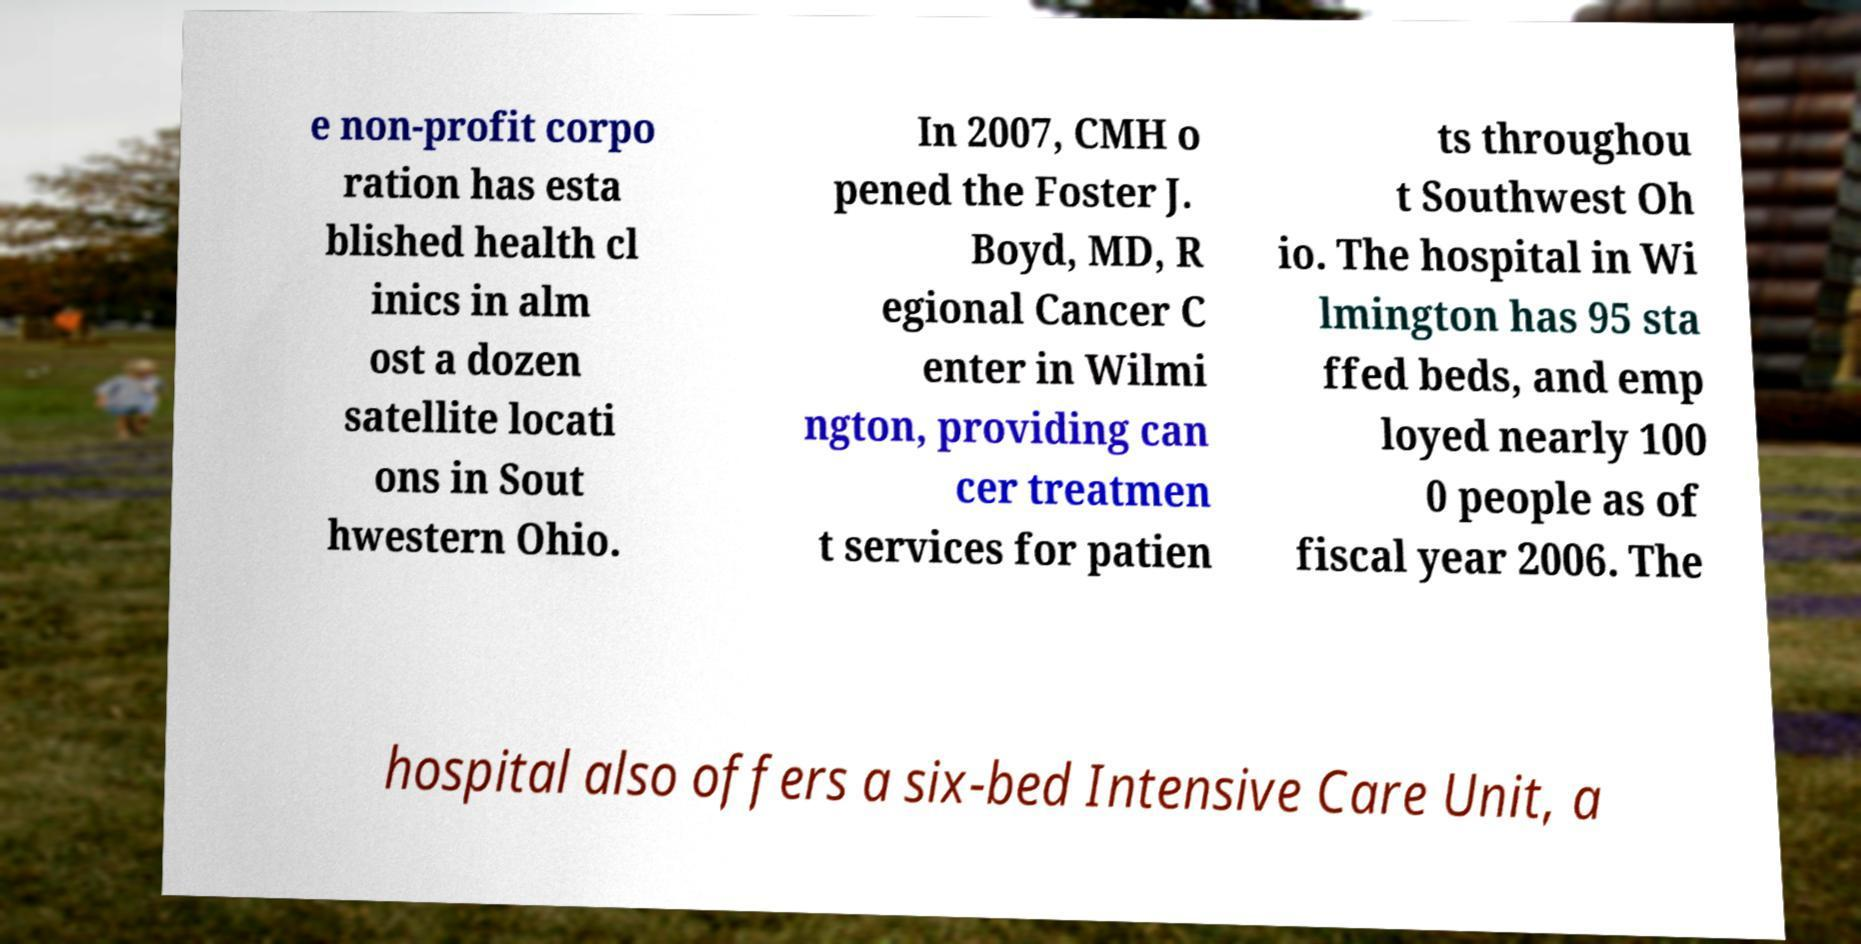Could you assist in decoding the text presented in this image and type it out clearly? e non-profit corpo ration has esta blished health cl inics in alm ost a dozen satellite locati ons in Sout hwestern Ohio. In 2007, CMH o pened the Foster J. Boyd, MD, R egional Cancer C enter in Wilmi ngton, providing can cer treatmen t services for patien ts throughou t Southwest Oh io. The hospital in Wi lmington has 95 sta ffed beds, and emp loyed nearly 100 0 people as of fiscal year 2006. The hospital also offers a six-bed Intensive Care Unit, a 